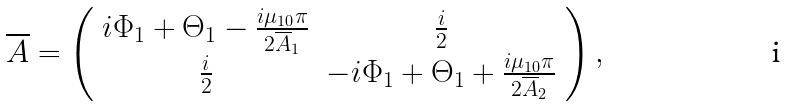<formula> <loc_0><loc_0><loc_500><loc_500>\overline { A } = \left ( \begin{array} { c c } i \Phi _ { 1 } + \Theta _ { 1 } - \frac { i \mu _ { 1 0 } \pi } { 2 \overline { A } _ { 1 } } & \frac { i } { 2 } \\ \frac { i } { 2 } & - i \Phi _ { 1 } + \Theta _ { 1 } + \frac { i \mu _ { 1 0 } \pi } { 2 \overline { A } _ { 2 } } \\ \end{array} \right ) ,</formula> 